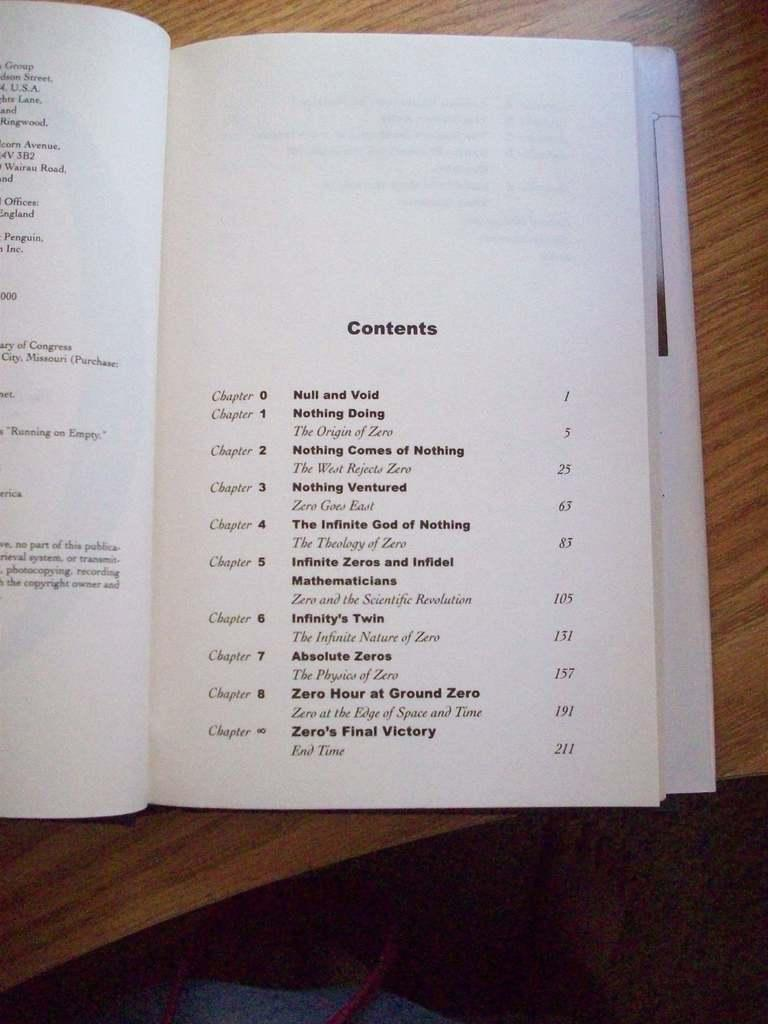<image>
Create a compact narrative representing the image presented. A book is opened on a table to the Contents page. 